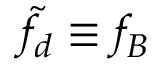<formula> <loc_0><loc_0><loc_500><loc_500>\tilde { f } _ { d } \equiv f _ { B }</formula> 